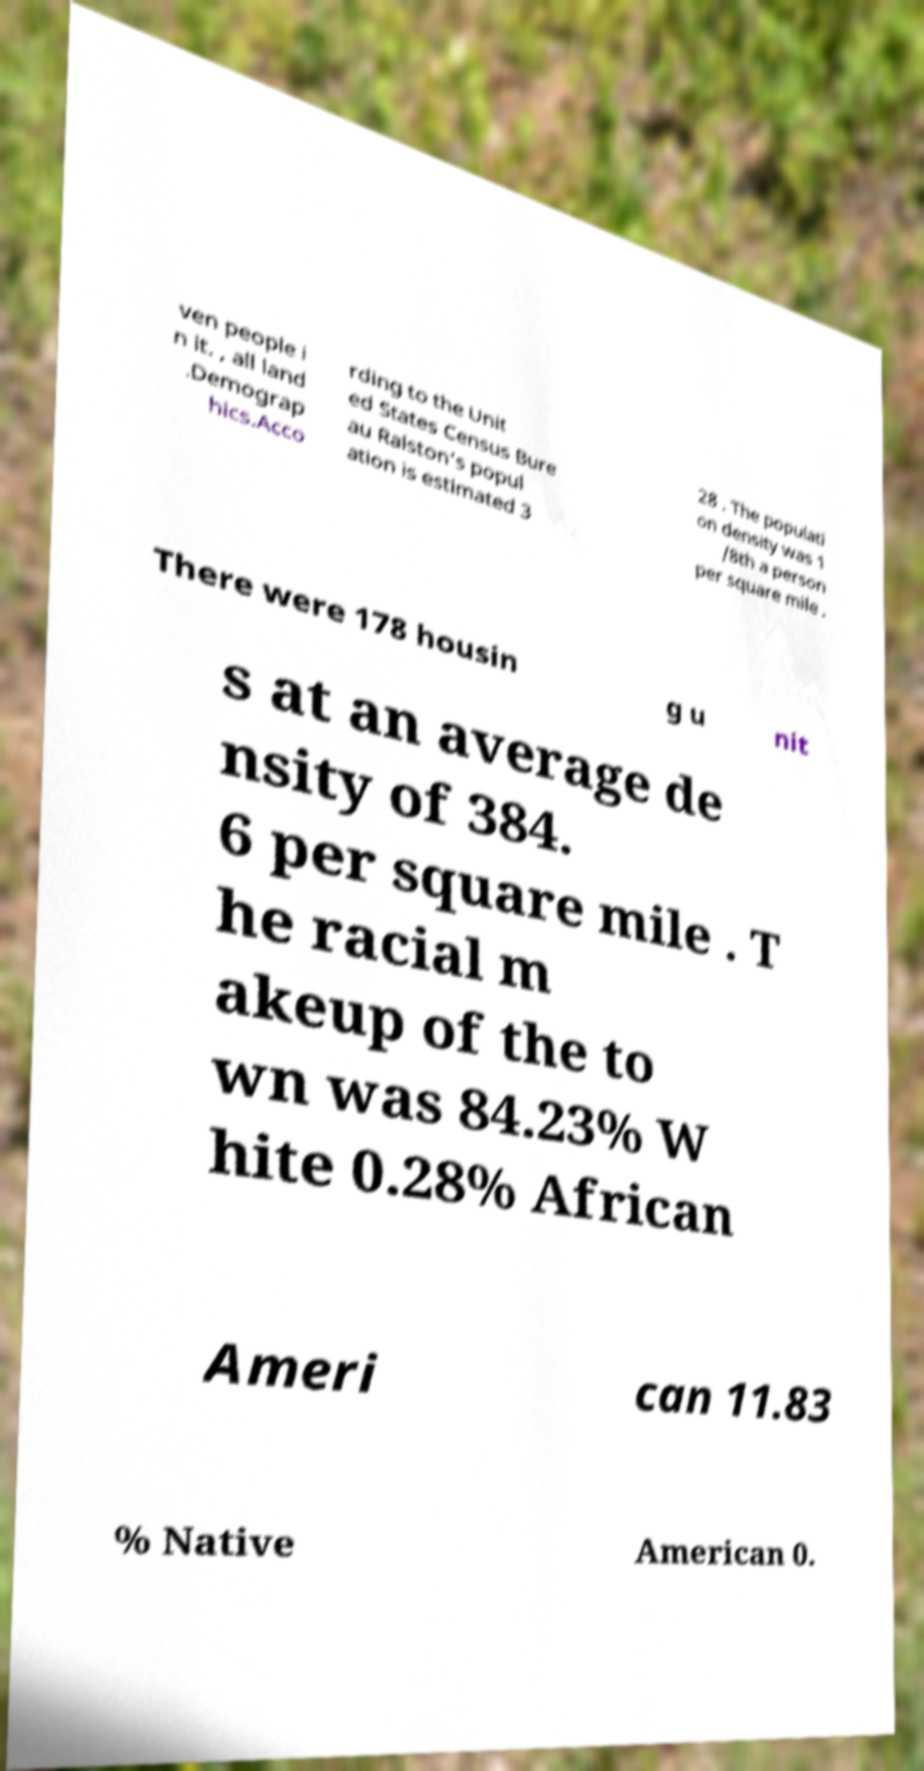There's text embedded in this image that I need extracted. Can you transcribe it verbatim? ven people i n it. , all land .Demograp hics.Acco rding to the Unit ed States Census Bure au Ralston's popul ation is estimated 3 28 . The populati on density was 1 /8th a person per square mile . There were 178 housin g u nit s at an average de nsity of 384. 6 per square mile . T he racial m akeup of the to wn was 84.23% W hite 0.28% African Ameri can 11.83 % Native American 0. 